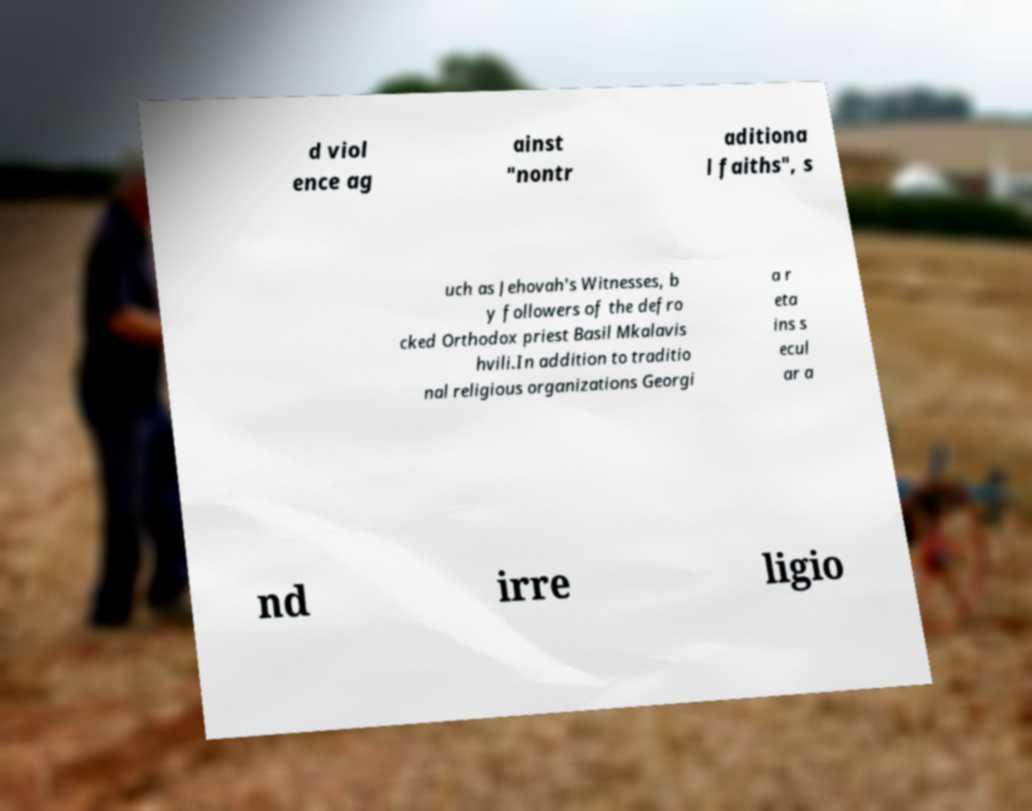What messages or text are displayed in this image? I need them in a readable, typed format. d viol ence ag ainst "nontr aditiona l faiths", s uch as Jehovah's Witnesses, b y followers of the defro cked Orthodox priest Basil Mkalavis hvili.In addition to traditio nal religious organizations Georgi a r eta ins s ecul ar a nd irre ligio 